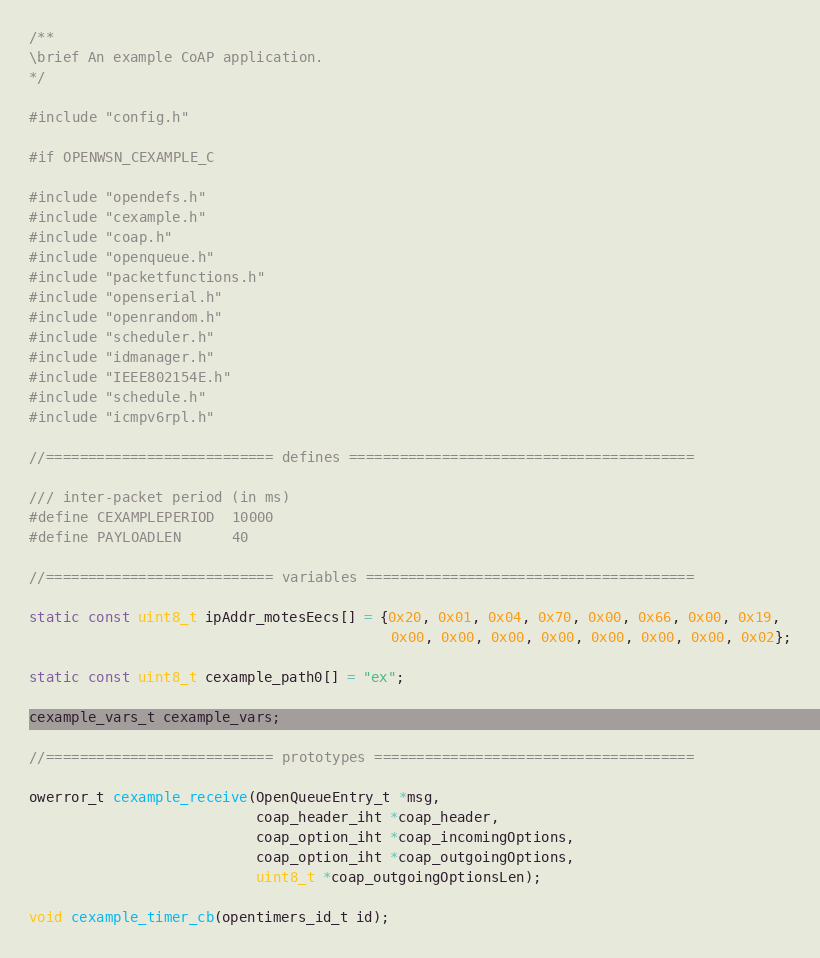<code> <loc_0><loc_0><loc_500><loc_500><_C_>/**
\brief An example CoAP application.
*/

#include "config.h"

#if OPENWSN_CEXAMPLE_C

#include "opendefs.h"
#include "cexample.h"
#include "coap.h"
#include "openqueue.h"
#include "packetfunctions.h"
#include "openserial.h"
#include "openrandom.h"
#include "scheduler.h"
#include "idmanager.h"
#include "IEEE802154E.h"
#include "schedule.h"
#include "icmpv6rpl.h"

//=========================== defines =========================================

/// inter-packet period (in ms)
#define CEXAMPLEPERIOD  10000
#define PAYLOADLEN      40

//=========================== variables =======================================

static const uint8_t ipAddr_motesEecs[] = {0x20, 0x01, 0x04, 0x70, 0x00, 0x66, 0x00, 0x19,
                                           0x00, 0x00, 0x00, 0x00, 0x00, 0x00, 0x00, 0x02};

static const uint8_t cexample_path0[] = "ex";

cexample_vars_t cexample_vars;

//=========================== prototypes ======================================

owerror_t cexample_receive(OpenQueueEntry_t *msg,
                           coap_header_iht *coap_header,
                           coap_option_iht *coap_incomingOptions,
                           coap_option_iht *coap_outgoingOptions,
                           uint8_t *coap_outgoingOptionsLen);

void cexample_timer_cb(opentimers_id_t id);</code> 